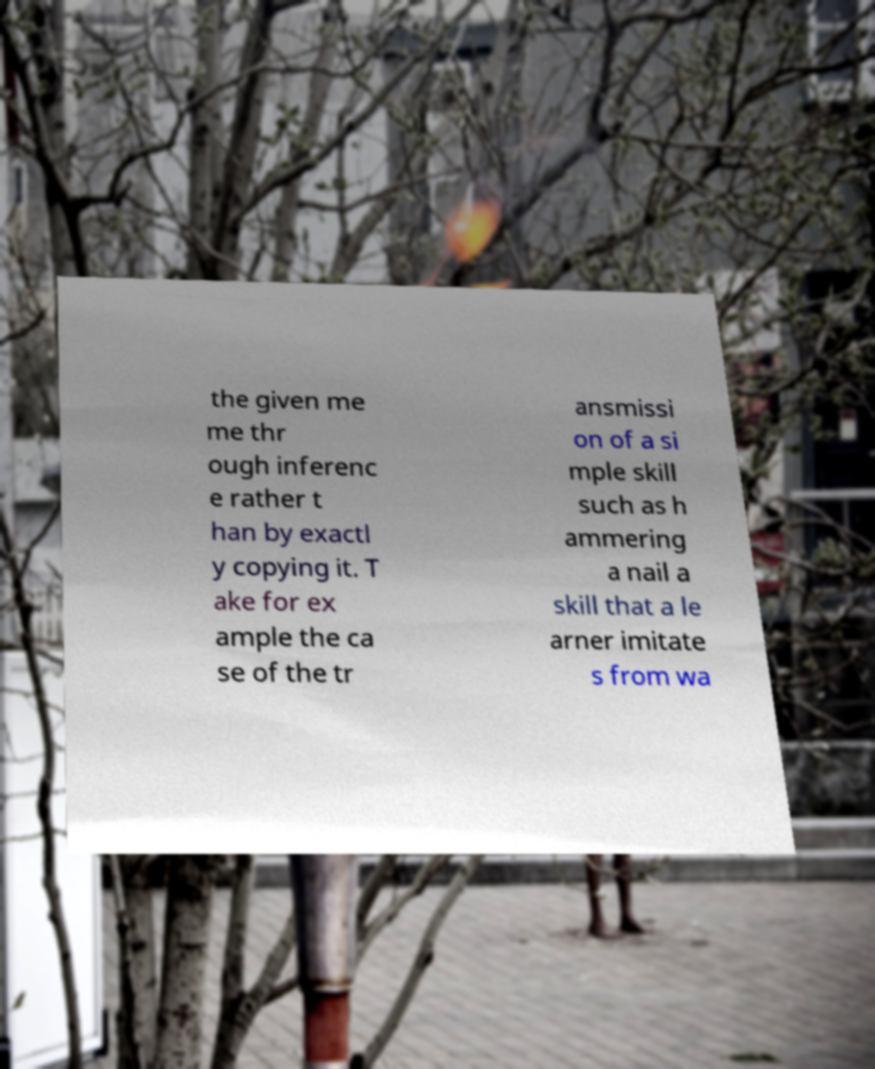What messages or text are displayed in this image? I need them in a readable, typed format. the given me me thr ough inferenc e rather t han by exactl y copying it. T ake for ex ample the ca se of the tr ansmissi on of a si mple skill such as h ammering a nail a skill that a le arner imitate s from wa 